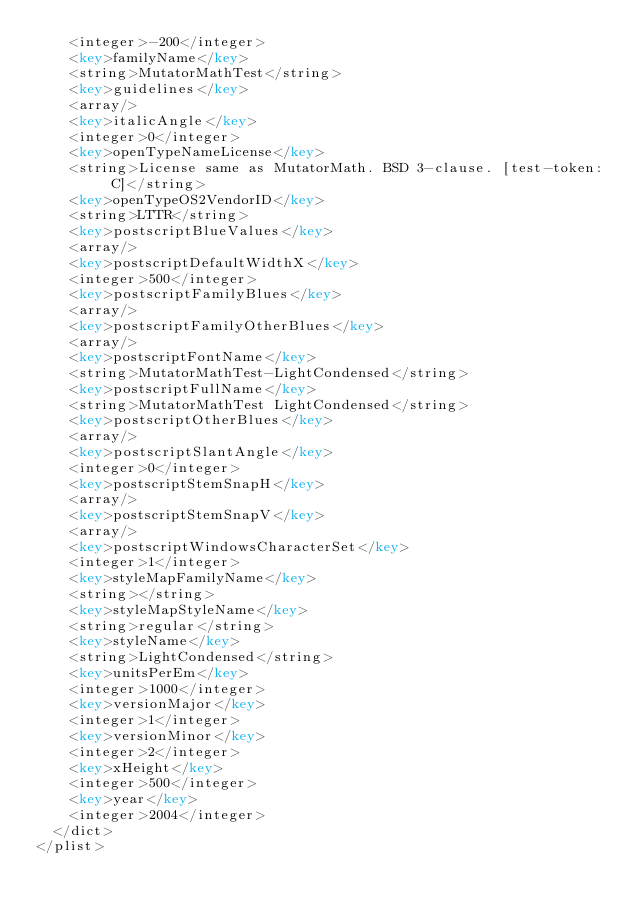<code> <loc_0><loc_0><loc_500><loc_500><_XML_>    <integer>-200</integer>
    <key>familyName</key>
    <string>MutatorMathTest</string>
    <key>guidelines</key>
    <array/>
    <key>italicAngle</key>
    <integer>0</integer>
    <key>openTypeNameLicense</key>
    <string>License same as MutatorMath. BSD 3-clause. [test-token: C]</string>
    <key>openTypeOS2VendorID</key>
    <string>LTTR</string>
    <key>postscriptBlueValues</key>
    <array/>
    <key>postscriptDefaultWidthX</key>
    <integer>500</integer>
    <key>postscriptFamilyBlues</key>
    <array/>
    <key>postscriptFamilyOtherBlues</key>
    <array/>
    <key>postscriptFontName</key>
    <string>MutatorMathTest-LightCondensed</string>
    <key>postscriptFullName</key>
    <string>MutatorMathTest LightCondensed</string>
    <key>postscriptOtherBlues</key>
    <array/>
    <key>postscriptSlantAngle</key>
    <integer>0</integer>
    <key>postscriptStemSnapH</key>
    <array/>
    <key>postscriptStemSnapV</key>
    <array/>
    <key>postscriptWindowsCharacterSet</key>
    <integer>1</integer>
    <key>styleMapFamilyName</key>
    <string></string>
    <key>styleMapStyleName</key>
    <string>regular</string>
    <key>styleName</key>
    <string>LightCondensed</string>
    <key>unitsPerEm</key>
    <integer>1000</integer>
    <key>versionMajor</key>
    <integer>1</integer>
    <key>versionMinor</key>
    <integer>2</integer>
    <key>xHeight</key>
    <integer>500</integer>
    <key>year</key>
    <integer>2004</integer>
  </dict>
</plist>
</code> 